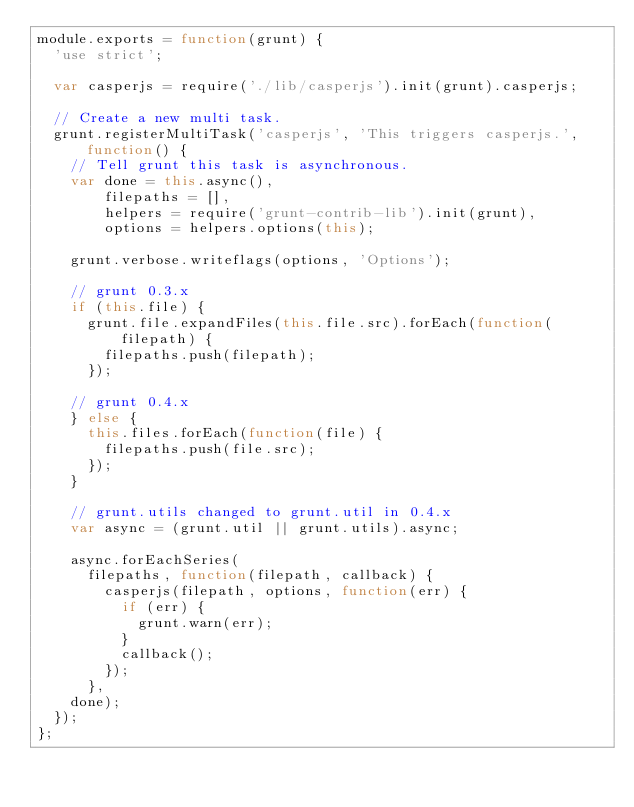Convert code to text. <code><loc_0><loc_0><loc_500><loc_500><_JavaScript_>module.exports = function(grunt) {
  'use strict';
  
  var casperjs = require('./lib/casperjs').init(grunt).casperjs;

  // Create a new multi task.
  grunt.registerMultiTask('casperjs', 'This triggers casperjs.', function() {
    // Tell grunt this task is asynchronous.
    var done = this.async(),
        filepaths = [],
        helpers = require('grunt-contrib-lib').init(grunt),
        options = helpers.options(this);

    grunt.verbose.writeflags(options, 'Options');

    // grunt 0.3.x
    if (this.file) {
      grunt.file.expandFiles(this.file.src).forEach(function(filepath) {
        filepaths.push(filepath);
      });

    // grunt 0.4.x
    } else {
      this.files.forEach(function(file) {
        filepaths.push(file.src);
      });
    }
    
    // grunt.utils changed to grunt.util in 0.4.x
    var async = (grunt.util || grunt.utils).async;

    async.forEachSeries(
      filepaths, function(filepath, callback) {
        casperjs(filepath, options, function(err) {
          if (err) {
            grunt.warn(err);
          }
          callback();
        });
      },
    done);
  });
};
</code> 